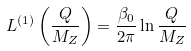<formula> <loc_0><loc_0><loc_500><loc_500>L ^ { ( 1 ) } \left ( \frac { Q } { M _ { Z } } \right ) = \frac { \beta _ { 0 } } { 2 \pi } \ln \frac { Q } { M _ { Z } }</formula> 